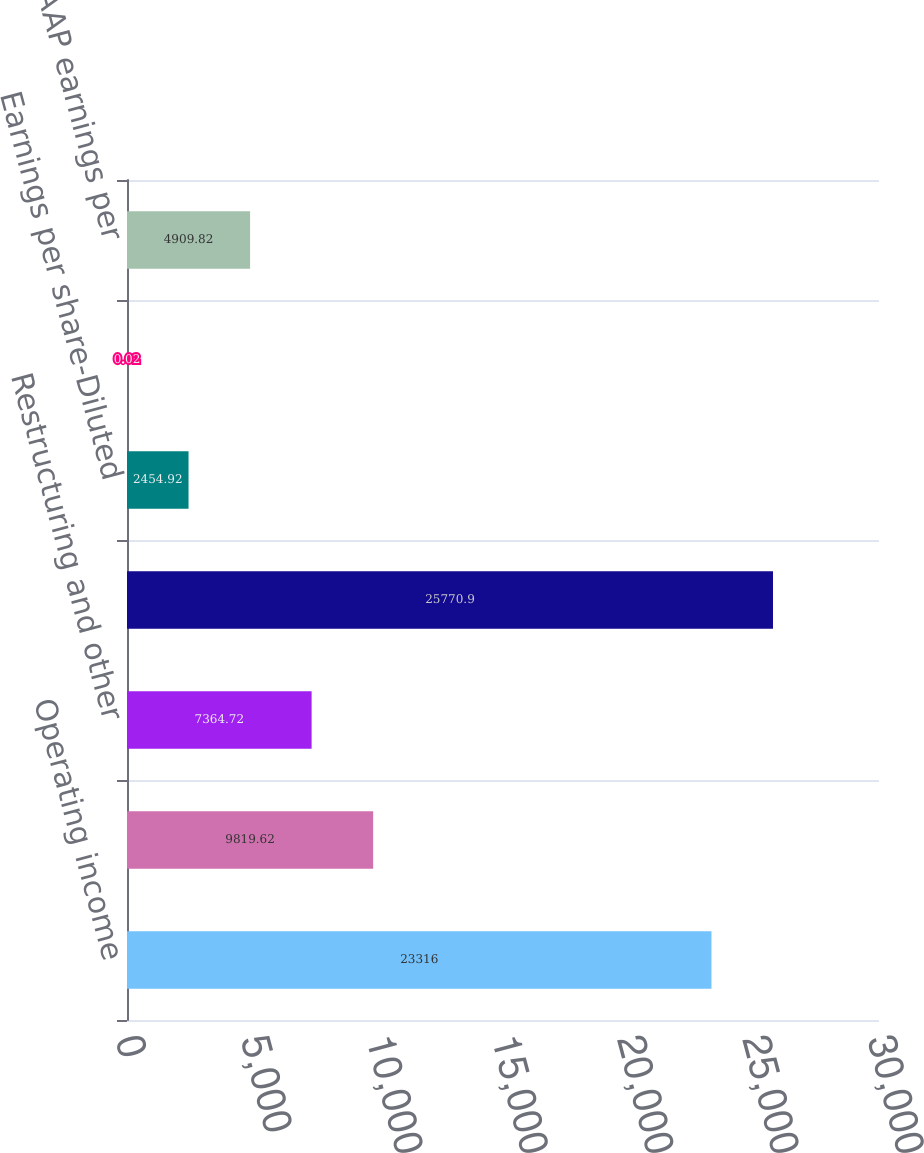Convert chart to OTSL. <chart><loc_0><loc_0><loc_500><loc_500><bar_chart><fcel>Operating income<fcel>Amortization of<fcel>Restructuring and other<fcel>Non-GAAP operating income<fcel>Earnings per share-Diluted<fcel>Income tax effect<fcel>Non-GAAP earnings per<nl><fcel>23316<fcel>9819.62<fcel>7364.72<fcel>25770.9<fcel>2454.92<fcel>0.02<fcel>4909.82<nl></chart> 